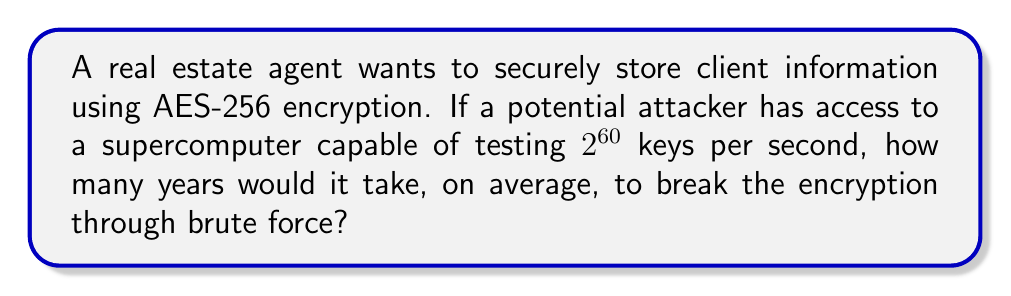Can you solve this math problem? To solve this problem, we need to follow these steps:

1. Determine the total number of possible keys for AES-256:
   AES-256 uses a 256-bit key, so the total number of possible keys is $2^{256}$.

2. Calculate the average number of keys that need to be tested:
   On average, an attacker would need to test half of all possible keys before finding the correct one. So, the average number of keys to test is:
   $$\frac{2^{256}}{2} = 2^{255}$$

3. Calculate the time needed to test all these keys:
   Time = (Number of keys to test) / (Keys tested per second)
   $$T = \frac{2^{255}}{2^{60}} = 2^{195} \text{ seconds}$$

4. Convert seconds to years:
   There are 31,536,000 seconds in a year (365 days * 24 hours * 60 minutes * 60 seconds).
   $$\text{Years} = \frac{2^{195}}{31,536,000} = \frac{2^{195}}{2^{24.91}} \approx 2^{170.09}$$

5. Simplify the result:
   $2^{170.09} \approx 1.5 \times 10^{51}$ years
Answer: $1.5 \times 10^{51}$ years 